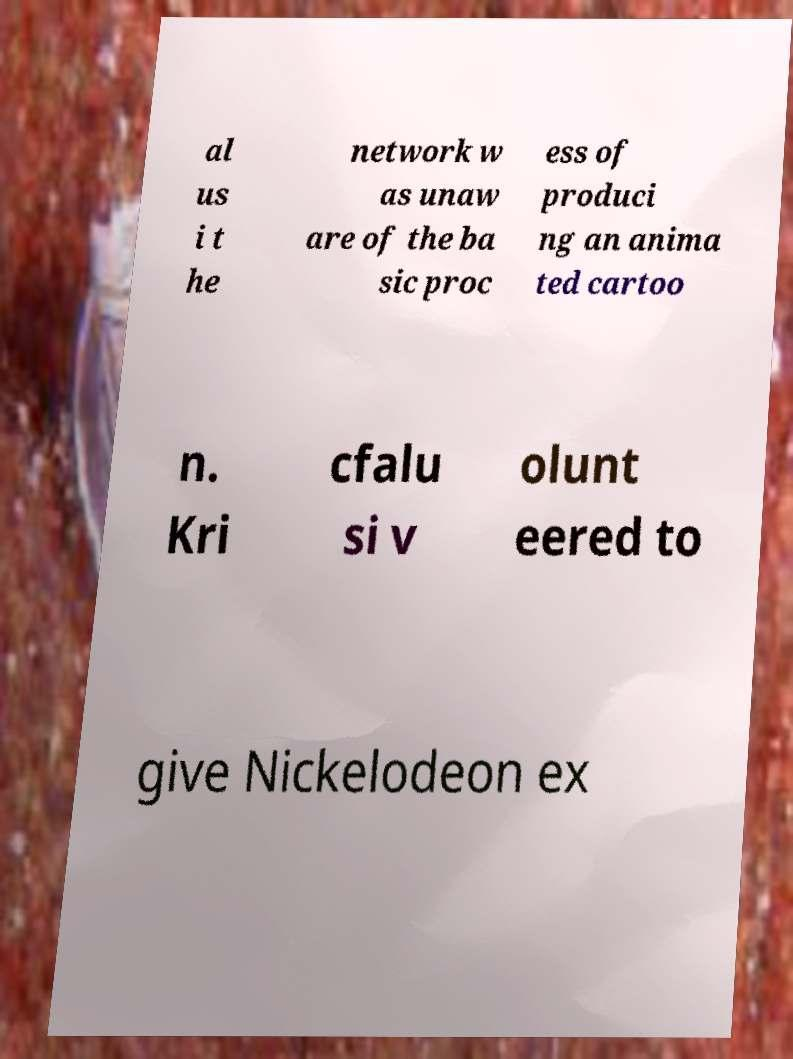Can you read and provide the text displayed in the image?This photo seems to have some interesting text. Can you extract and type it out for me? al us i t he network w as unaw are of the ba sic proc ess of produci ng an anima ted cartoo n. Kri cfalu si v olunt eered to give Nickelodeon ex 